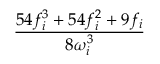<formula> <loc_0><loc_0><loc_500><loc_500>\frac { 5 4 f _ { i } ^ { 3 } + 5 4 f _ { i } ^ { 2 } + 9 f _ { i } } { 8 \omega _ { i } ^ { 3 } }</formula> 